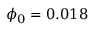<formula> <loc_0><loc_0><loc_500><loc_500>\phi _ { 0 } = 0 . 0 1 8</formula> 